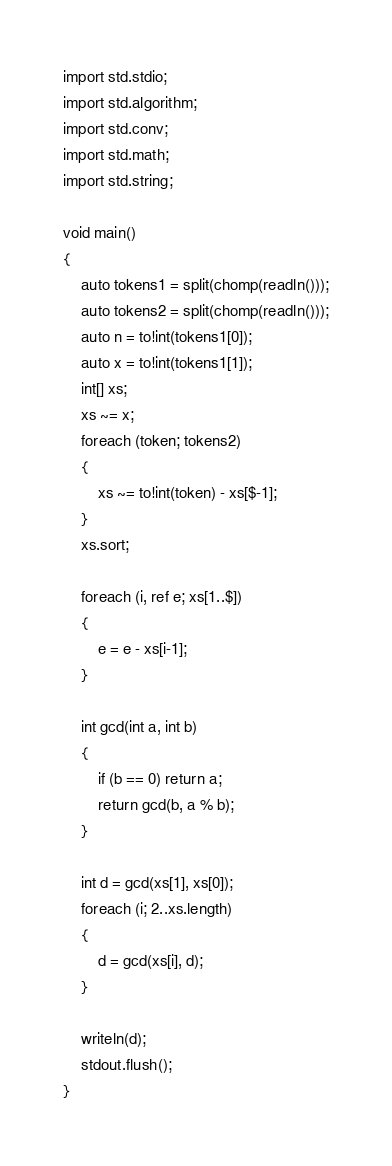Convert code to text. <code><loc_0><loc_0><loc_500><loc_500><_D_>import std.stdio;
import std.algorithm;
import std.conv;
import std.math;
import std.string;

void main()
{
	auto tokens1 = split(chomp(readln()));
	auto tokens2 = split(chomp(readln()));
	auto n = to!int(tokens1[0]);
	auto x = to!int(tokens1[1]);
	int[] xs;
	xs ~= x;
	foreach (token; tokens2)
	{
		xs ~= to!int(token) - xs[$-1];
	}
	xs.sort;

	foreach (i, ref e; xs[1..$])
	{
		e = e - xs[i-1];
	}

	int gcd(int a, int b)
	{
		if (b == 0) return a;
		return gcd(b, a % b);
	}

	int d = gcd(xs[1], xs[0]);
	foreach (i; 2..xs.length)
	{
		d = gcd(xs[i], d);
	}

	writeln(d);
	stdout.flush();
}</code> 